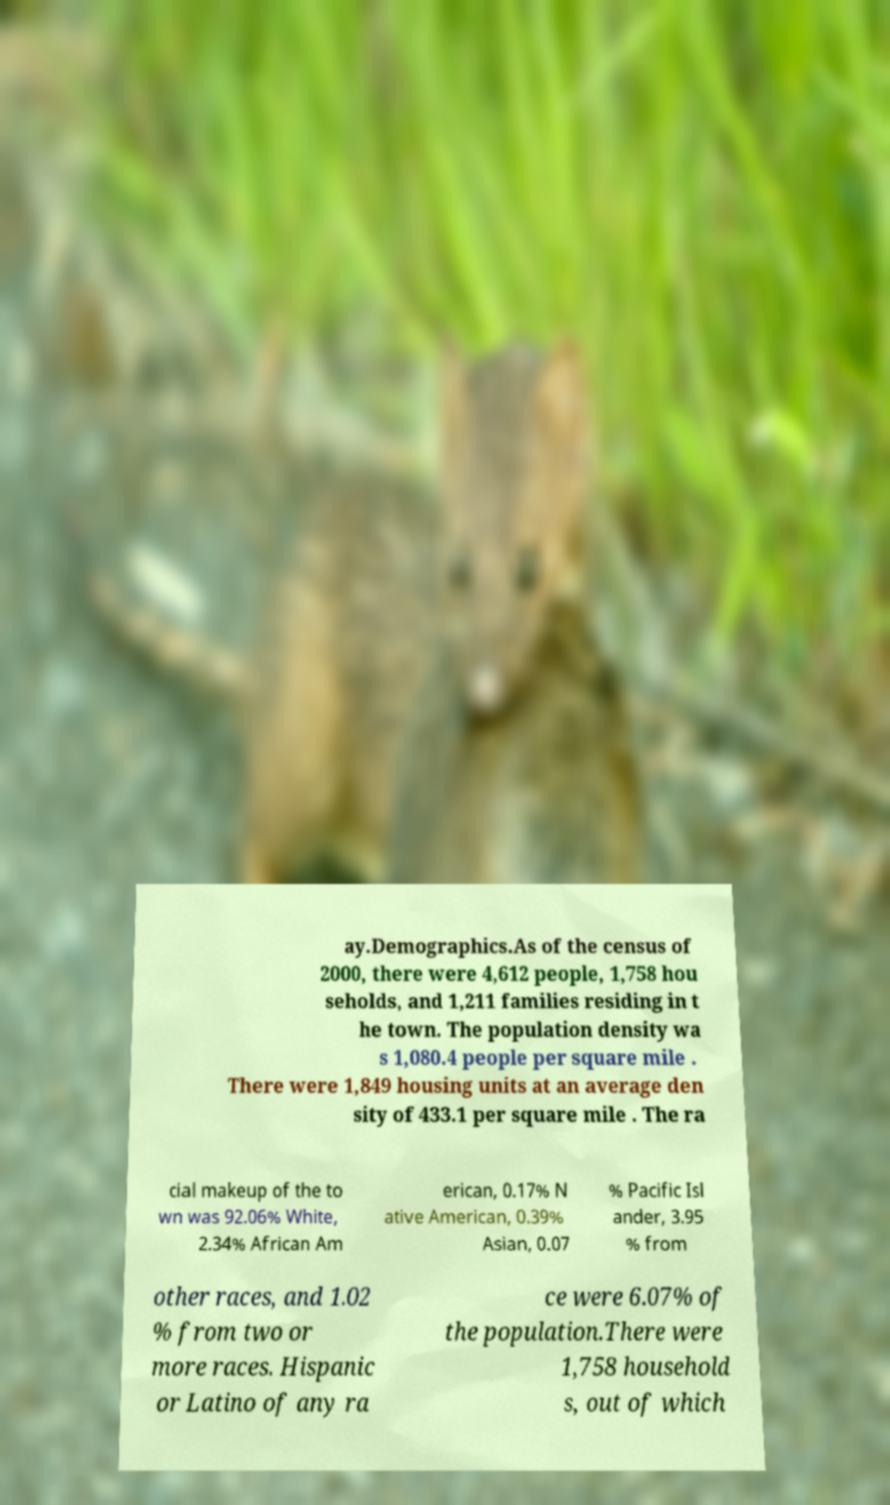I need the written content from this picture converted into text. Can you do that? ay.Demographics.As of the census of 2000, there were 4,612 people, 1,758 hou seholds, and 1,211 families residing in t he town. The population density wa s 1,080.4 people per square mile . There were 1,849 housing units at an average den sity of 433.1 per square mile . The ra cial makeup of the to wn was 92.06% White, 2.34% African Am erican, 0.17% N ative American, 0.39% Asian, 0.07 % Pacific Isl ander, 3.95 % from other races, and 1.02 % from two or more races. Hispanic or Latino of any ra ce were 6.07% of the population.There were 1,758 household s, out of which 